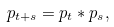Convert formula to latex. <formula><loc_0><loc_0><loc_500><loc_500>p _ { t + s } = p _ { t } \ast p _ { s } ,</formula> 